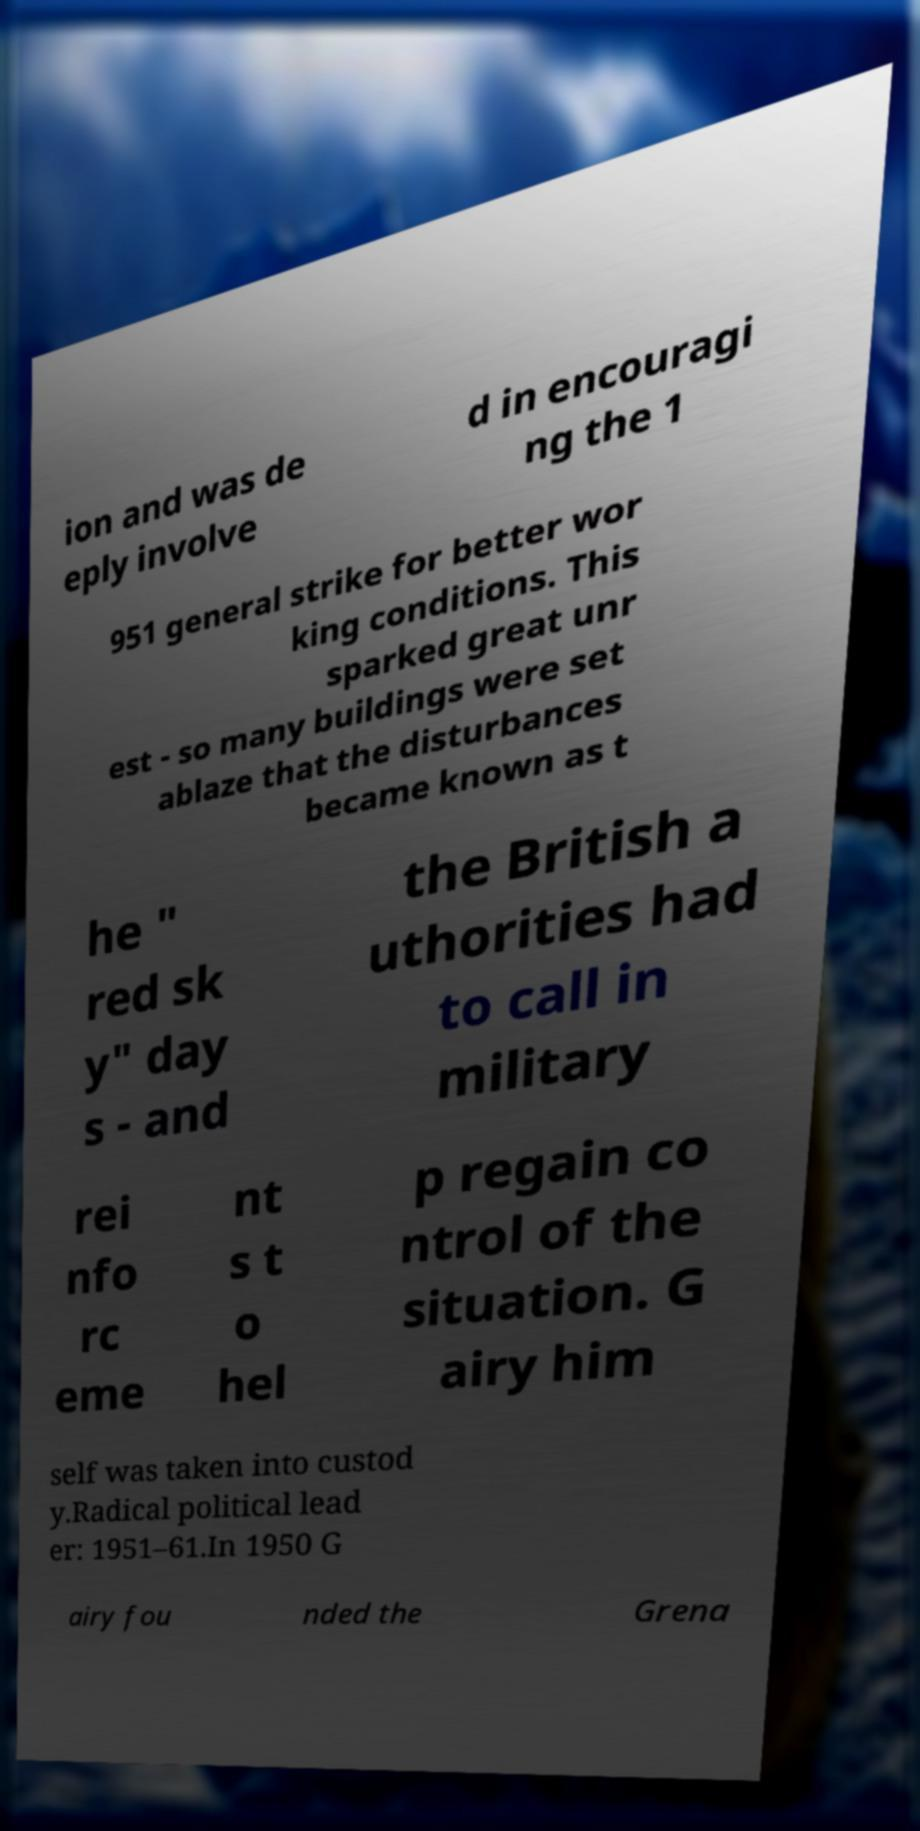Can you read and provide the text displayed in the image?This photo seems to have some interesting text. Can you extract and type it out for me? ion and was de eply involve d in encouragi ng the 1 951 general strike for better wor king conditions. This sparked great unr est - so many buildings were set ablaze that the disturbances became known as t he " red sk y" day s - and the British a uthorities had to call in military rei nfo rc eme nt s t o hel p regain co ntrol of the situation. G airy him self was taken into custod y.Radical political lead er: 1951–61.In 1950 G airy fou nded the Grena 